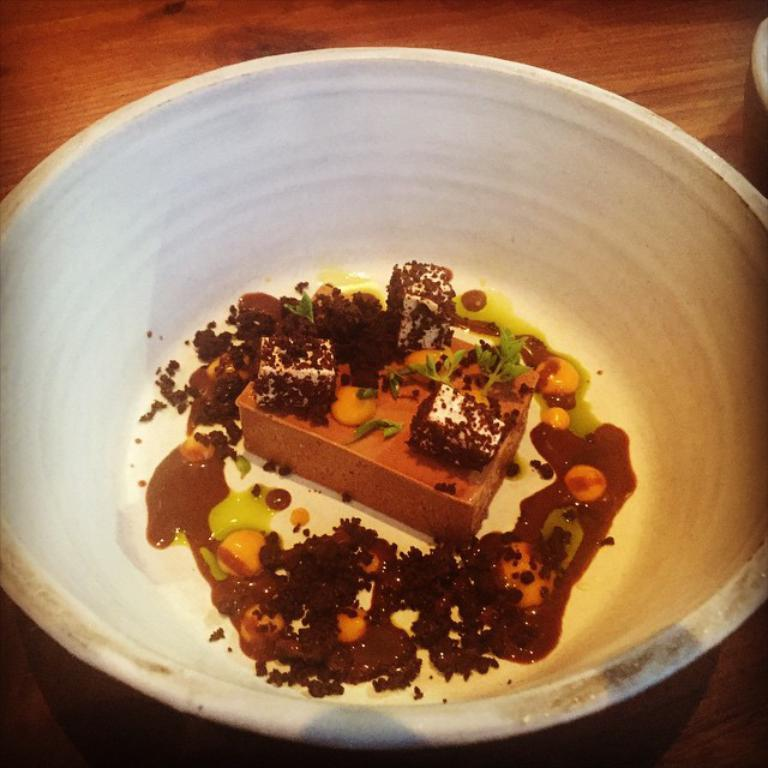What is in the bowl that is visible in the image? There is a food item in a bowl in the image. Where is the bowl located in the image? The bowl is placed on a table. What type of rose is present in the image? There is no rose present in the image; it features a food item in a bowl placed on a table. What decision is being made in the image? There is no indication of a decision being made in the image. 